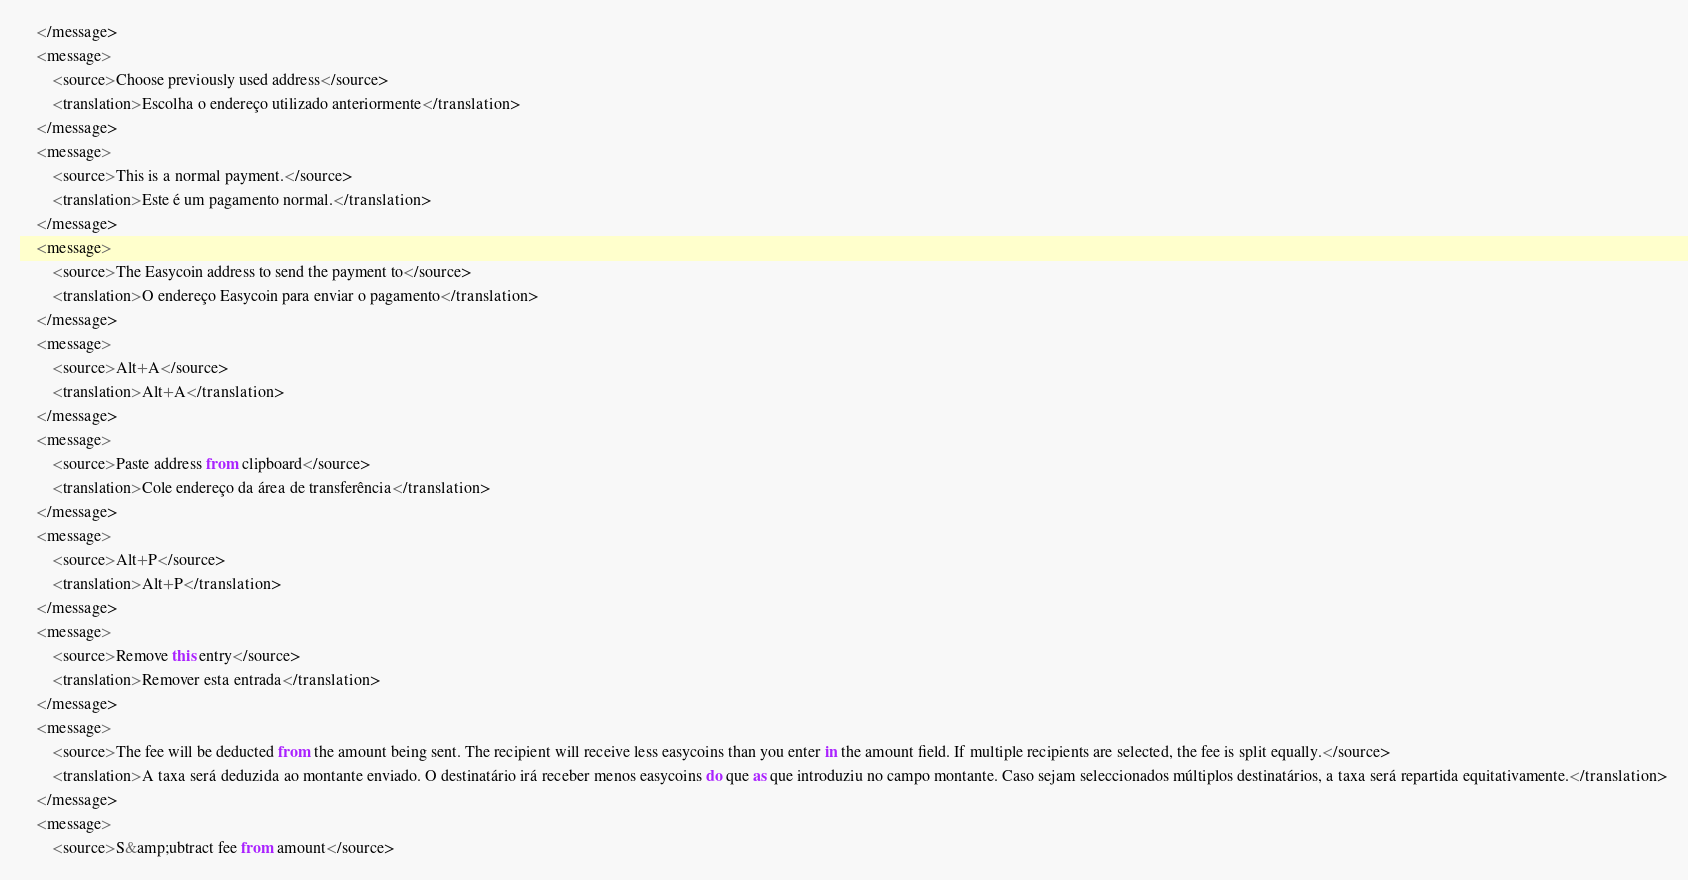Convert code to text. <code><loc_0><loc_0><loc_500><loc_500><_TypeScript_>    </message>
    <message>
        <source>Choose previously used address</source>
        <translation>Escolha o endereço utilizado anteriormente</translation>
    </message>
    <message>
        <source>This is a normal payment.</source>
        <translation>Este é um pagamento normal.</translation>
    </message>
    <message>
        <source>The Easycoin address to send the payment to</source>
        <translation>O endereço Easycoin para enviar o pagamento</translation>
    </message>
    <message>
        <source>Alt+A</source>
        <translation>Alt+A</translation>
    </message>
    <message>
        <source>Paste address from clipboard</source>
        <translation>Cole endereço da área de transferência</translation>
    </message>
    <message>
        <source>Alt+P</source>
        <translation>Alt+P</translation>
    </message>
    <message>
        <source>Remove this entry</source>
        <translation>Remover esta entrada</translation>
    </message>
    <message>
        <source>The fee will be deducted from the amount being sent. The recipient will receive less easycoins than you enter in the amount field. If multiple recipients are selected, the fee is split equally.</source>
        <translation>A taxa será deduzida ao montante enviado. O destinatário irá receber menos easycoins do que as que introduziu no campo montante. Caso sejam seleccionados múltiplos destinatários, a taxa será repartida equitativamente.</translation>
    </message>
    <message>
        <source>S&amp;ubtract fee from amount</source></code> 